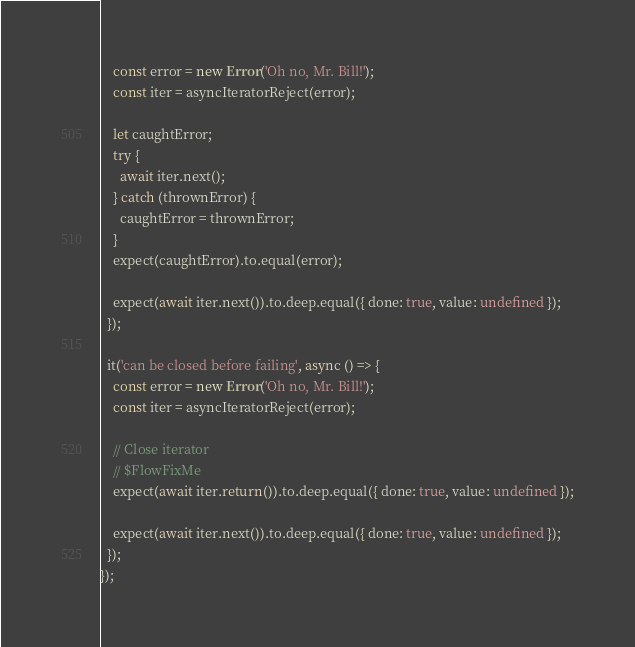<code> <loc_0><loc_0><loc_500><loc_500><_JavaScript_>    const error = new Error('Oh no, Mr. Bill!');
    const iter = asyncIteratorReject(error);

    let caughtError;
    try {
      await iter.next();
    } catch (thrownError) {
      caughtError = thrownError;
    }
    expect(caughtError).to.equal(error);

    expect(await iter.next()).to.deep.equal({ done: true, value: undefined });
  });

  it('can be closed before failing', async () => {
    const error = new Error('Oh no, Mr. Bill!');
    const iter = asyncIteratorReject(error);

    // Close iterator
    // $FlowFixMe
    expect(await iter.return()).to.deep.equal({ done: true, value: undefined });

    expect(await iter.next()).to.deep.equal({ done: true, value: undefined });
  });
});
</code> 